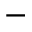<formula> <loc_0><loc_0><loc_500><loc_500>-</formula> 